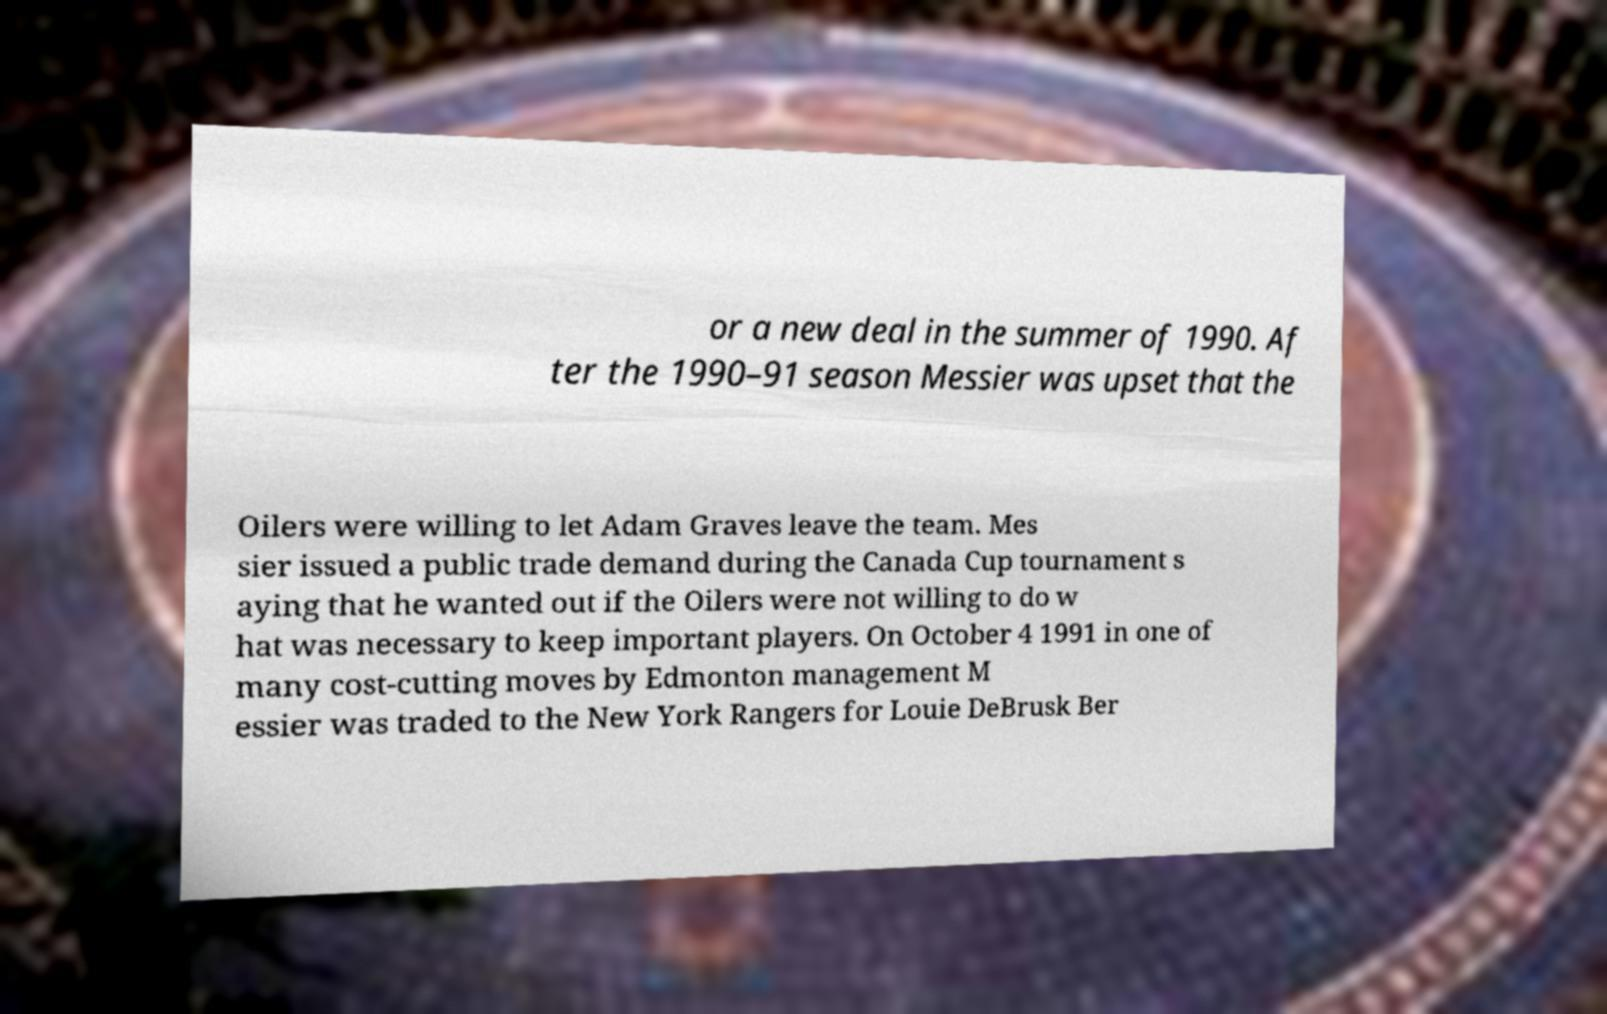Can you accurately transcribe the text from the provided image for me? or a new deal in the summer of 1990. Af ter the 1990–91 season Messier was upset that the Oilers were willing to let Adam Graves leave the team. Mes sier issued a public trade demand during the Canada Cup tournament s aying that he wanted out if the Oilers were not willing to do w hat was necessary to keep important players. On October 4 1991 in one of many cost-cutting moves by Edmonton management M essier was traded to the New York Rangers for Louie DeBrusk Ber 